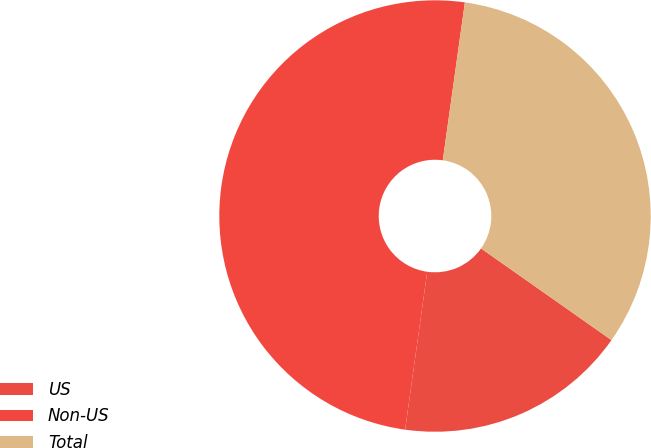<chart> <loc_0><loc_0><loc_500><loc_500><pie_chart><fcel>US<fcel>Non-US<fcel>Total<nl><fcel>17.46%<fcel>50.0%<fcel>32.54%<nl></chart> 